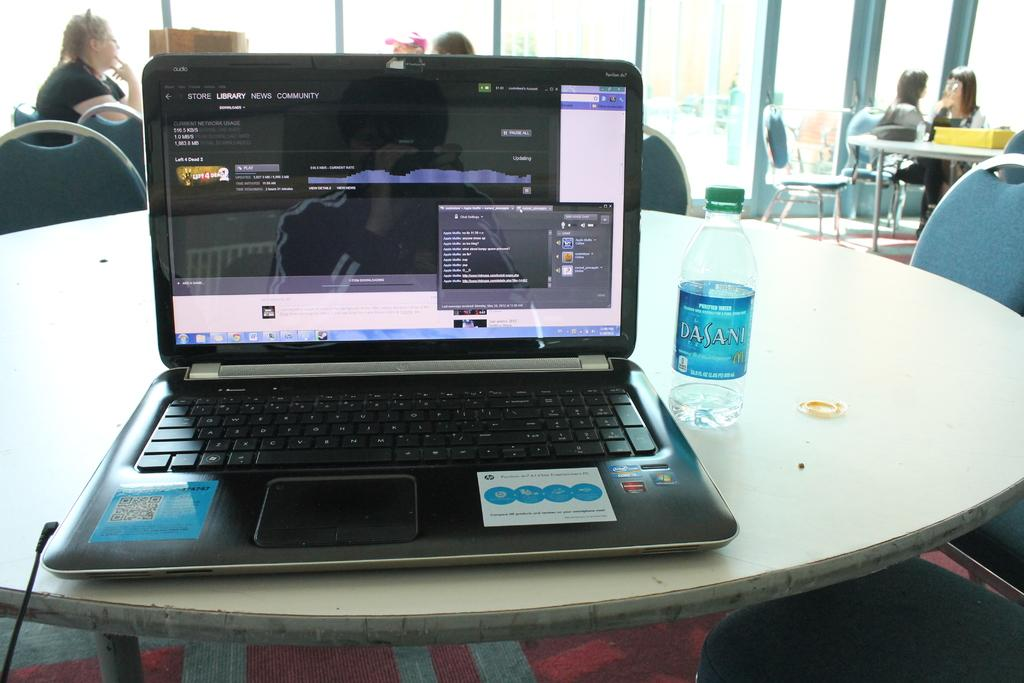<image>
Give a short and clear explanation of the subsequent image. A bottle of Dasani water rests next to a laptop with an unlocked screen. 